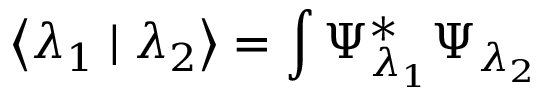Convert formula to latex. <formula><loc_0><loc_0><loc_500><loc_500>\left < \lambda _ { 1 } | \lambda _ { 2 } \right > = \int \Psi _ { \lambda _ { 1 } } ^ { * } \Psi _ { \lambda _ { 2 } }</formula> 